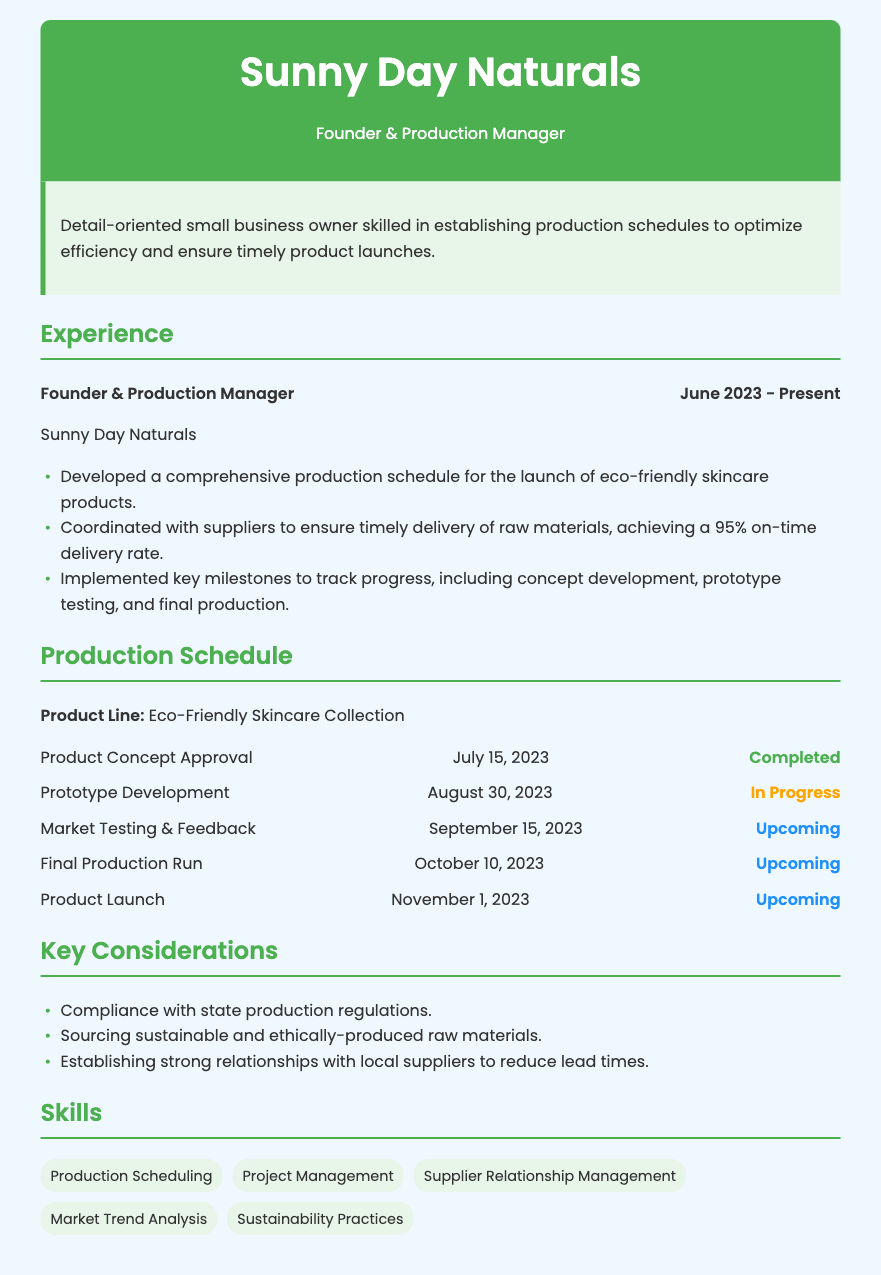what is the name of the business? The header of the document states the name of the business, which is Sunny Day Naturals.
Answer: Sunny Day Naturals who is the founder and production manager? The document mentions that the founder and production manager is the same person as stated in the header.
Answer: Founder & Production Manager when was the product concept approval completed? The Production Schedule section provides the date for the completion of product concept approval.
Answer: July 15, 2023 what is the status of prototype development? The milestone section states the current status of prototype development.
Answer: In Progress what is the upcoming product launch date? The document specifies the date for the product launch in the Production Schedule.
Answer: November 1, 2023 how many key considerations are listed? The Key Considerations section includes a list, which can be counted to determine the total.
Answer: 3 which skills are listed under the skills section? The Skills section provides various skills that the founder possesses.
Answer: Production Scheduling, Project Management, Supplier Relationship Management, Market Trend Analysis, Sustainability Practices what is the product line name? The document states the name of the product line in the Production Schedule section.
Answer: Eco-Friendly Skincare Collection what percentage was achieved for on-time delivery of raw materials? The experience item mentions the achievement percentage for the timely delivery of raw materials.
Answer: 95% 